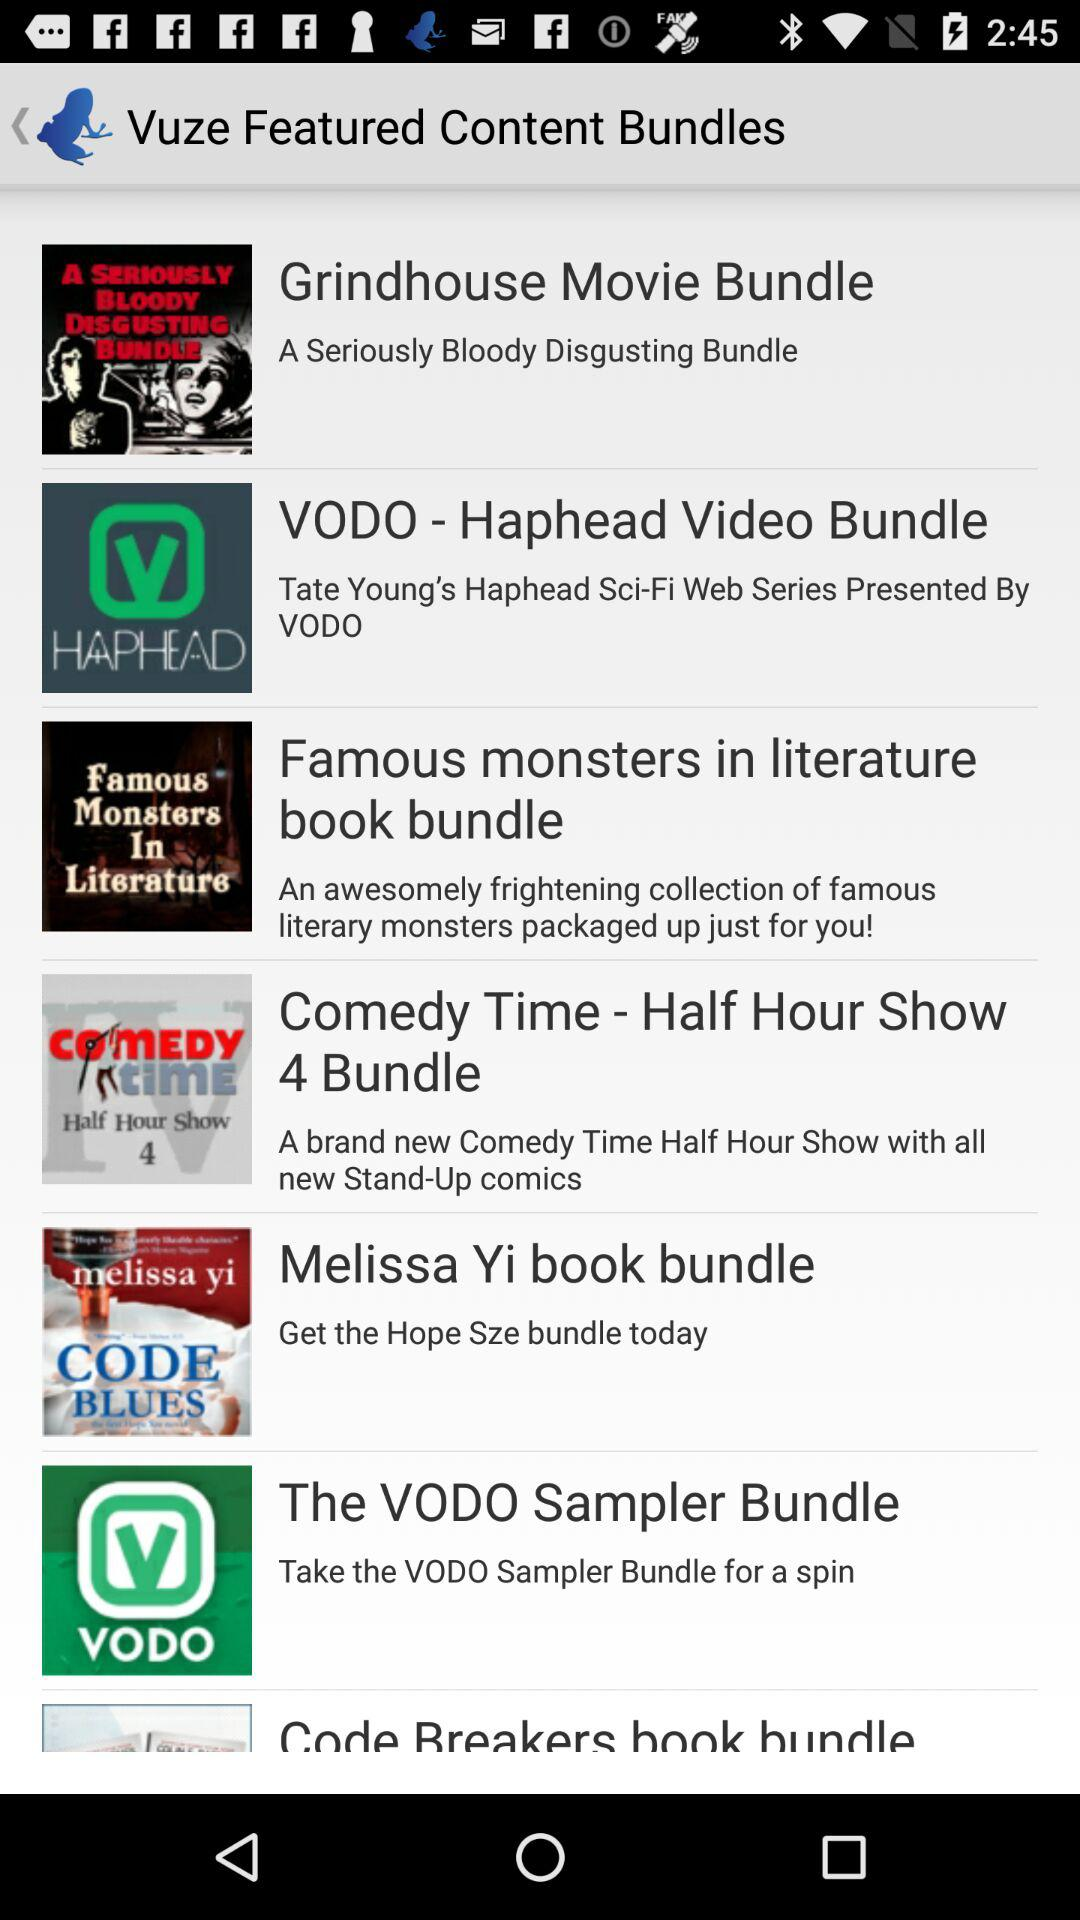How many bundles are there in total?
Answer the question using a single word or phrase. 7 